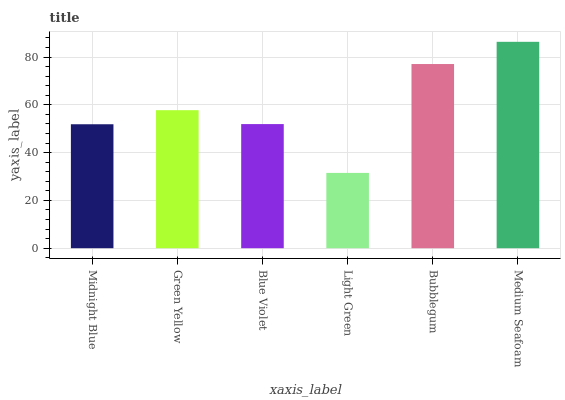Is Light Green the minimum?
Answer yes or no. Yes. Is Medium Seafoam the maximum?
Answer yes or no. Yes. Is Green Yellow the minimum?
Answer yes or no. No. Is Green Yellow the maximum?
Answer yes or no. No. Is Green Yellow greater than Midnight Blue?
Answer yes or no. Yes. Is Midnight Blue less than Green Yellow?
Answer yes or no. Yes. Is Midnight Blue greater than Green Yellow?
Answer yes or no. No. Is Green Yellow less than Midnight Blue?
Answer yes or no. No. Is Green Yellow the high median?
Answer yes or no. Yes. Is Blue Violet the low median?
Answer yes or no. Yes. Is Light Green the high median?
Answer yes or no. No. Is Light Green the low median?
Answer yes or no. No. 